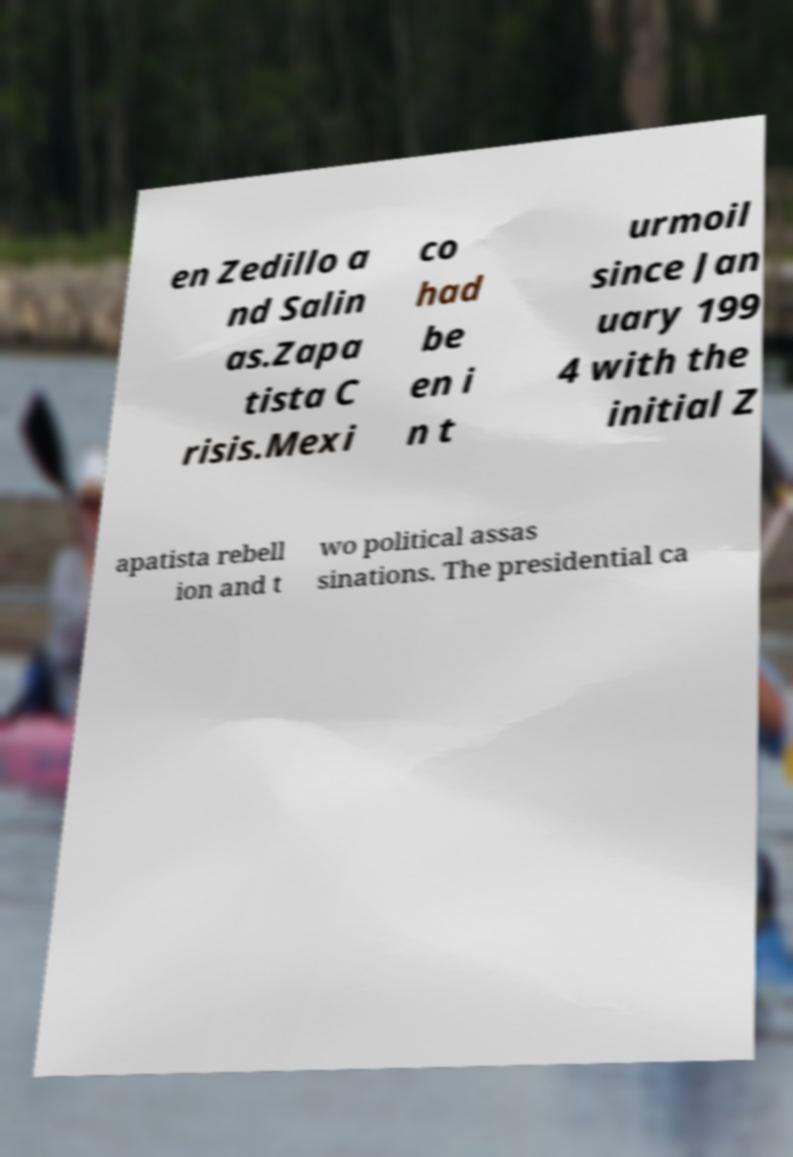What messages or text are displayed in this image? I need them in a readable, typed format. en Zedillo a nd Salin as.Zapa tista C risis.Mexi co had be en i n t urmoil since Jan uary 199 4 with the initial Z apatista rebell ion and t wo political assas sinations. The presidential ca 